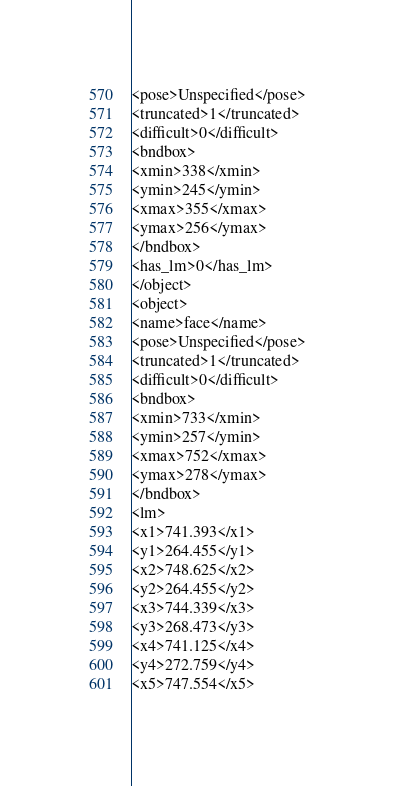<code> <loc_0><loc_0><loc_500><loc_500><_XML_><pose>Unspecified</pose>
<truncated>1</truncated>
<difficult>0</difficult>
<bndbox>
<xmin>338</xmin>
<ymin>245</ymin>
<xmax>355</xmax>
<ymax>256</ymax>
</bndbox>
<has_lm>0</has_lm>
</object>
<object>
<name>face</name>
<pose>Unspecified</pose>
<truncated>1</truncated>
<difficult>0</difficult>
<bndbox>
<xmin>733</xmin>
<ymin>257</ymin>
<xmax>752</xmax>
<ymax>278</ymax>
</bndbox>
<lm>
<x1>741.393</x1>
<y1>264.455</y1>
<x2>748.625</x2>
<y2>264.455</y2>
<x3>744.339</x3>
<y3>268.473</y3>
<x4>741.125</x4>
<y4>272.759</y4>
<x5>747.554</x5></code> 